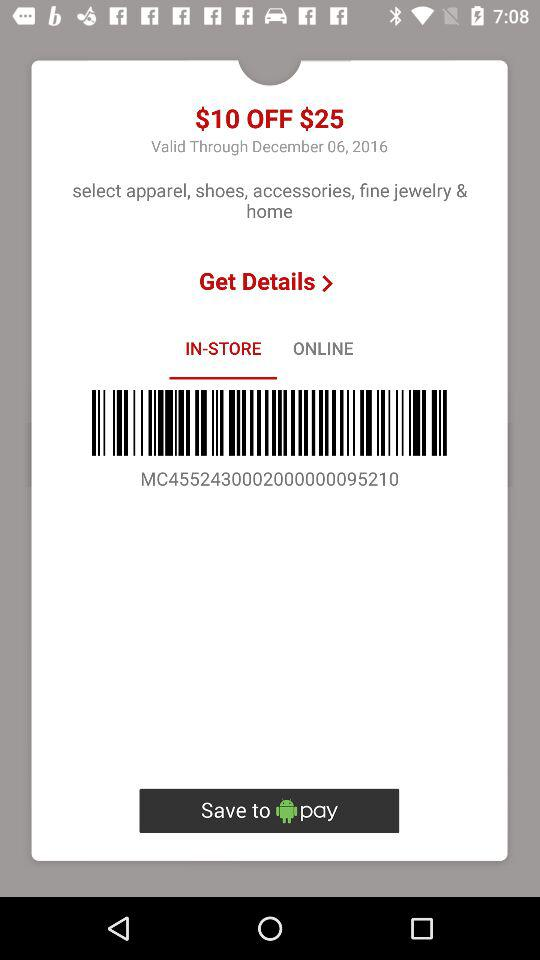What is the expiry date of this coupon? The expiry date is December 06, 2016. 